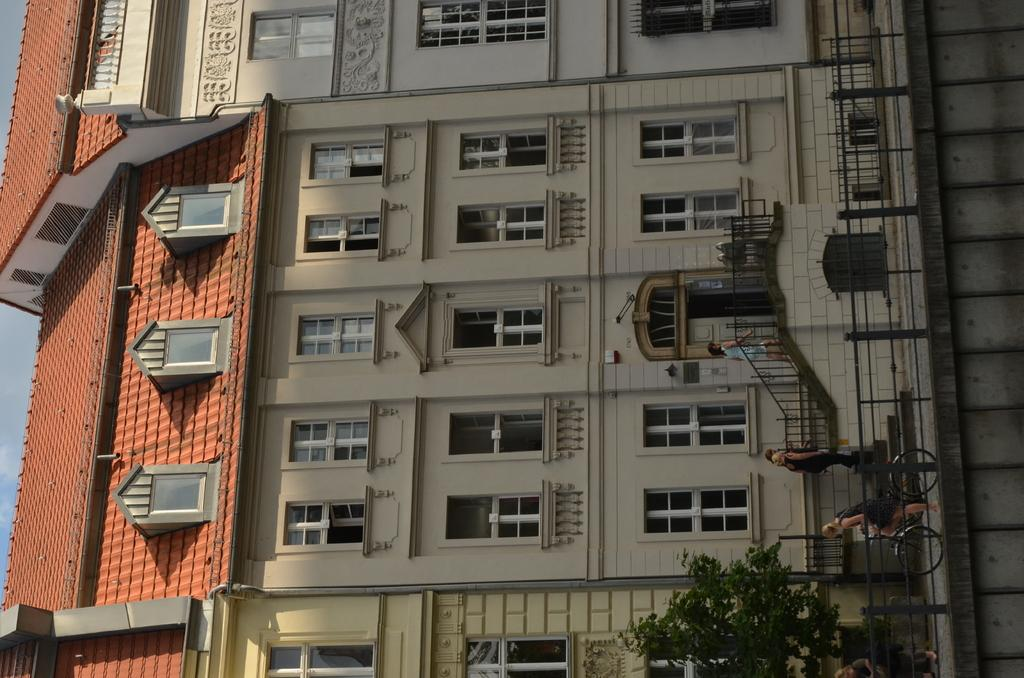What type of structures can be seen in the image? There are buildings in the image. What natural element is present in the image? There is a tree in the image. What activity are some people engaged in? There are people climbing stairs in the image. What mode of transportation is being used by a woman in the image? There is a woman on a bicycle in the image. How would you describe the sky in the image? The sky is blue and cloudy in the image. Can you see any roses growing near the tree in the image? There are no roses visible in the image; only a tree is present. Is the scene in the image particularly quiet? The presence of people climbing stairs and a woman on a bicycle suggests that the scene is not quiet. 